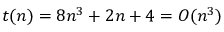<formula> <loc_0><loc_0><loc_500><loc_500>t ( n ) = 8 n ^ { 3 } + 2 n + 4 = O ( n ^ { 3 } )</formula> 